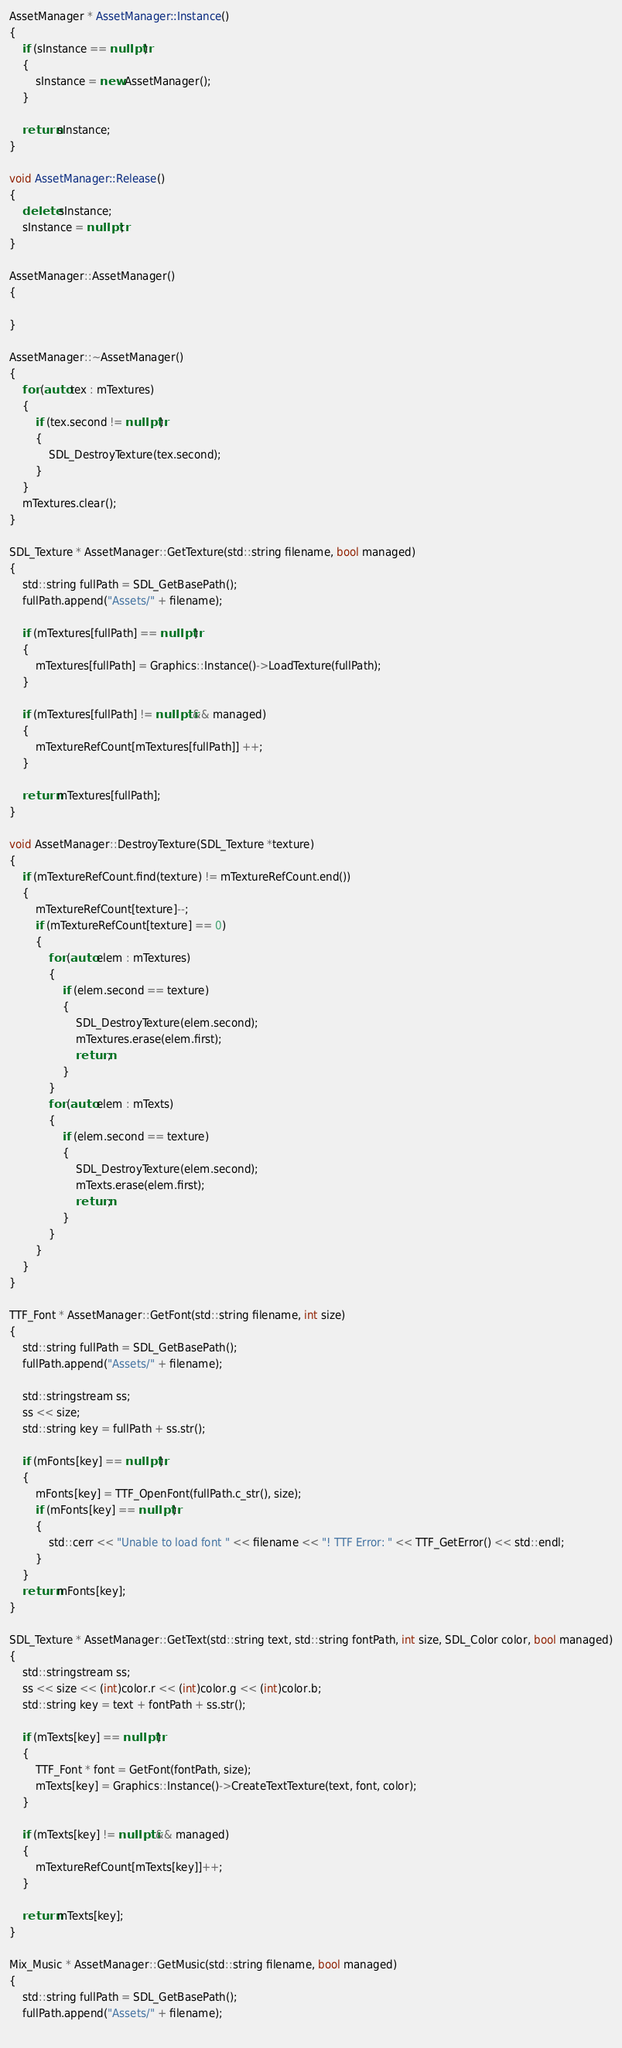Convert code to text. <code><loc_0><loc_0><loc_500><loc_500><_C++_>
AssetManager * AssetManager::Instance()
{
	if (sInstance == nullptr)
	{
		sInstance = new AssetManager();
	}
	
	return sInstance;
}

void AssetManager::Release()
{
	delete sInstance;
	sInstance = nullptr;
}

AssetManager::AssetManager()
{
	
}

AssetManager::~AssetManager()
{
	for (auto tex : mTextures)
	{
		if (tex.second != nullptr)
		{
			SDL_DestroyTexture(tex.second);
		}
	}
	mTextures.clear();
}

SDL_Texture * AssetManager::GetTexture(std::string filename, bool managed)
{
	std::string fullPath = SDL_GetBasePath();
	fullPath.append("Assets/" + filename);
	
	if (mTextures[fullPath] == nullptr)
	{
		mTextures[fullPath] = Graphics::Instance()->LoadTexture(fullPath);
	}
	
	if (mTextures[fullPath] != nullptr && managed)
	{
		mTextureRefCount[mTextures[fullPath]] ++;
	}
	
	return mTextures[fullPath];
}

void AssetManager::DestroyTexture(SDL_Texture *texture)
{
	if (mTextureRefCount.find(texture) != mTextureRefCount.end())
	{
		mTextureRefCount[texture]--;
		if (mTextureRefCount[texture] == 0)
		{
			for (auto elem : mTextures)
			{
				if (elem.second == texture)
				{
					SDL_DestroyTexture(elem.second);
					mTextures.erase(elem.first);
					return;
				}
			}
			for (auto elem : mTexts)
			{
				if (elem.second == texture)
				{
					SDL_DestroyTexture(elem.second);
					mTexts.erase(elem.first);
					return;
				}
			}
		}
	}
}

TTF_Font * AssetManager::GetFont(std::string filename, int size)
{
	std::string fullPath = SDL_GetBasePath();
	fullPath.append("Assets/" + filename);
	
	std::stringstream ss;
	ss << size;
	std::string key = fullPath + ss.str();
	
	if (mFonts[key] == nullptr)
	{
		mFonts[key] = TTF_OpenFont(fullPath.c_str(), size);
		if (mFonts[key] == nullptr)
		{
			std::cerr << "Unable to load font " << filename << "! TTF Error: " << TTF_GetError() << std::endl;
		}
	}
	return mFonts[key];
}

SDL_Texture * AssetManager::GetText(std::string text, std::string fontPath, int size, SDL_Color color, bool managed)
{
	std::stringstream ss;
	ss << size << (int)color.r << (int)color.g << (int)color.b;
	std::string key = text + fontPath + ss.str();
	
	if (mTexts[key] == nullptr)
	{
		TTF_Font * font = GetFont(fontPath, size);
		mTexts[key] = Graphics::Instance()->CreateTextTexture(text, font, color);
	}
	
	if (mTexts[key] != nullptr && managed)
	{
		mTextureRefCount[mTexts[key]]++;
	}
	
	return mTexts[key];
}

Mix_Music * AssetManager::GetMusic(std::string filename, bool managed)
{
	std::string fullPath = SDL_GetBasePath();
	fullPath.append("Assets/" + filename);
	</code> 